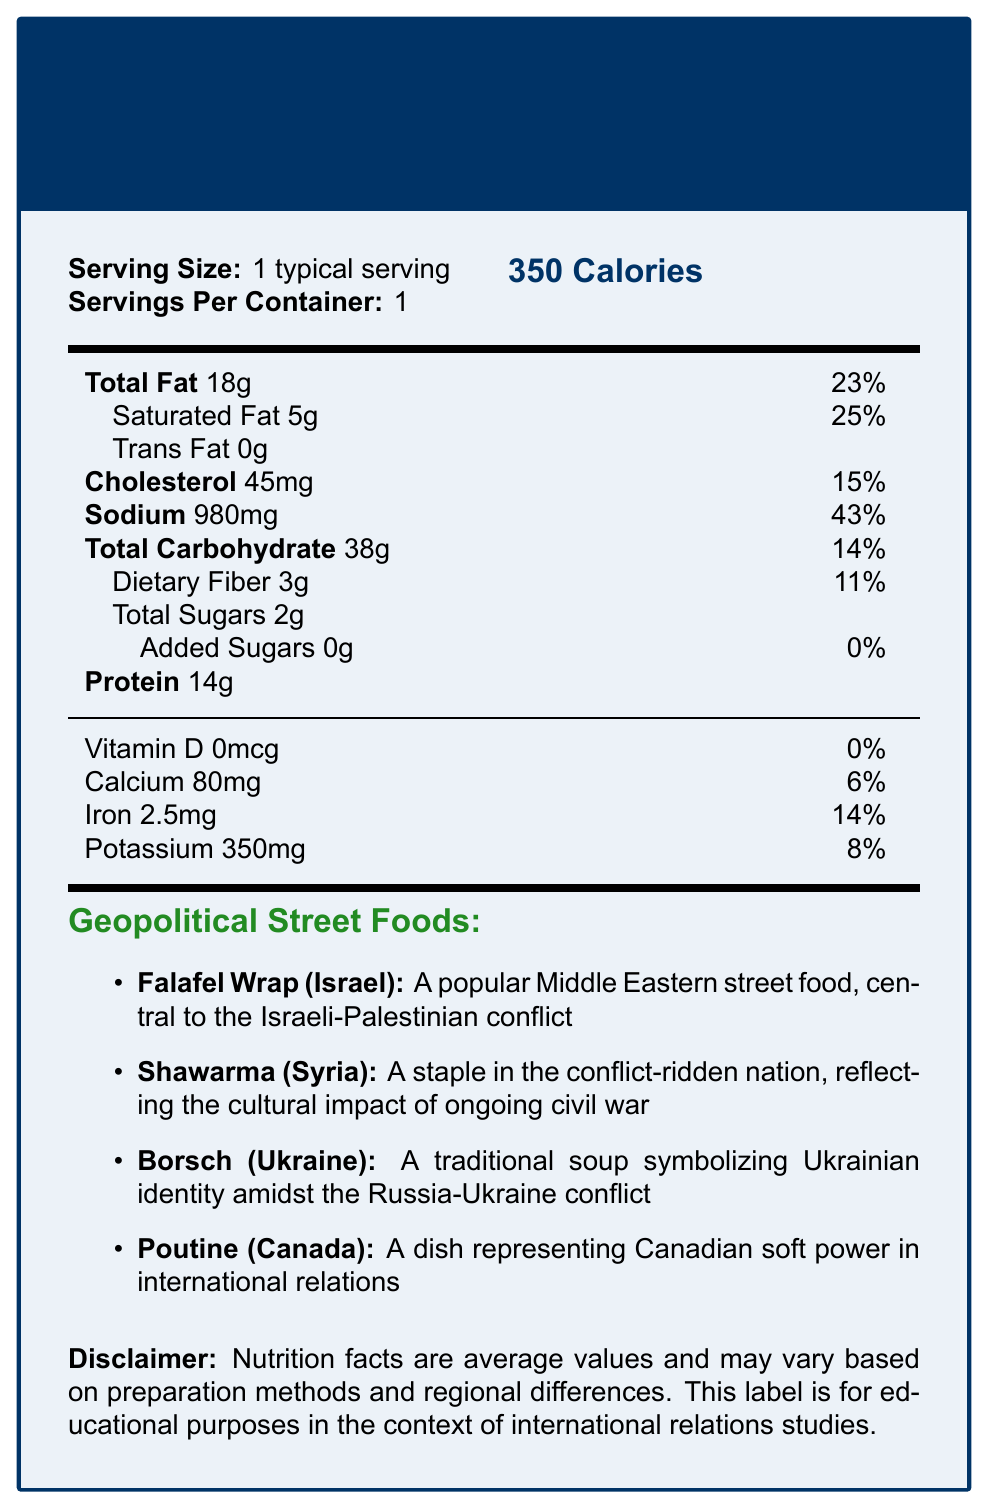what is the serving size? According to the document, the serving size is labeled as "1 typical serving."
Answer: 1 typical serving how much protein does one serving contain? The document specifies that one serving contains 14g of protein.
Answer: 14g which country is associated with the food item "Borsch"? In the document, Borsch is listed as being from Ukraine.
Answer: Ukraine what is the daily value percentage of saturated fat? The document states that the daily value percentage for saturated fat is 25%.
Answer: 25% how much sodium does one serving contain? It is mentioned in the document that one serving contains 980mg of sodium.
Answer: 980mg which street food item is linked to the Israeli-Palestinian conflict? A. Falafel Wrap B. Shawarma C. Borsch D. Poutine The document associates Falafel Wrap with the Israeli-Palestinian conflict.
Answer: A. Falafel Wrap which ingredient is not found in a Poutine? 1. French fries 2. Gravy 3. Cheese curds 4. Sour cream The document lists French fries, Gravy, and Cheese curds as ingredients in Poutine, but not Sour cream.
Answer: 4. Sour cream is there any vitamin D in a serving? The document states there is 0mcg of Vitamin D in a serving, which is 0% of the daily value.
Answer: No summarize the main idea of the document. The document starts with basic nutritional information and follows with specific details about street foods from Israel, Syria, Ukraine, and Canada, connecting them to their geopolitical context and discussing their nutritional impact.
Answer: The document provides a detailed analysis of the nutritional content of various street foods from countries involved in geopolitical conflicts, highlighting their cultural and economic significance. how does street food contribute to cultural preservation? The document discusses that traditional recipes help preserve cultural identity even during geopolitical conflicts.
Answer: Traditional recipes maintain cultural identity during geopolitical upheavals. what is the total carbohydrate content per serving? The document lists the total carbohydrate content per serving as 38g.
Answer: 38g what percentage of the daily value for iron is in one serving? According to the document, one serving provides 14% of the daily value for iron.
Answer: 14% list the ingredients in a Shawarma. The document lists these ingredients under Shawarma from Syria.
Answer: Marinated meat, flatbread, garlic sauce, vegetables can the document provide details about the protein sources in the foods? While the document lists the protein content and ingredients of each food item, it does not specify which ingredients are the main sources of protein.
Answer: Not enough information 